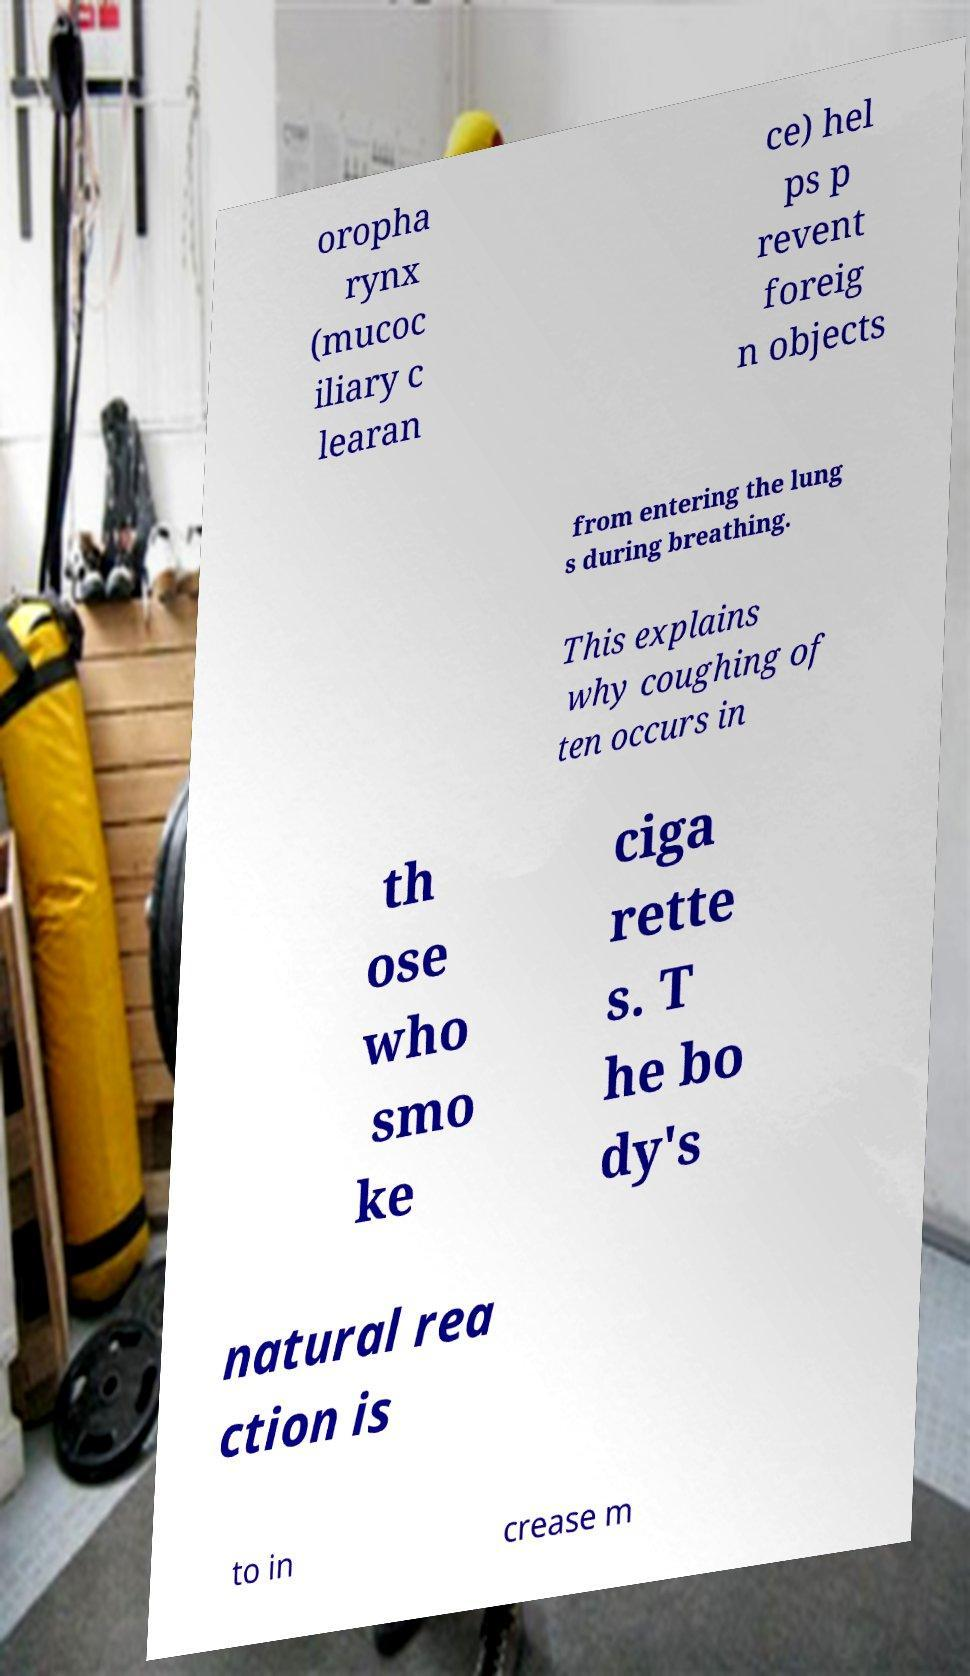I need the written content from this picture converted into text. Can you do that? oropha rynx (mucoc iliary c learan ce) hel ps p revent foreig n objects from entering the lung s during breathing. This explains why coughing of ten occurs in th ose who smo ke ciga rette s. T he bo dy's natural rea ction is to in crease m 